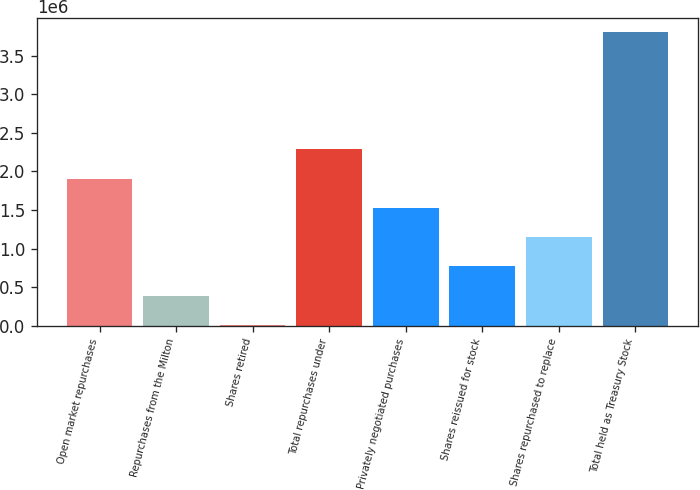<chart> <loc_0><loc_0><loc_500><loc_500><bar_chart><fcel>Open market repurchases<fcel>Repurchases from the Milton<fcel>Shares retired<fcel>Total repurchases under<fcel>Privately negotiated purchases<fcel>Shares reissued for stock<fcel>Shares repurchased to replace<fcel>Total held as Treasury Stock<nl><fcel>1.90738e+06<fcel>391733<fcel>12820<fcel>2.2863e+06<fcel>1.52847e+06<fcel>770645<fcel>1.14956e+06<fcel>3.80195e+06<nl></chart> 